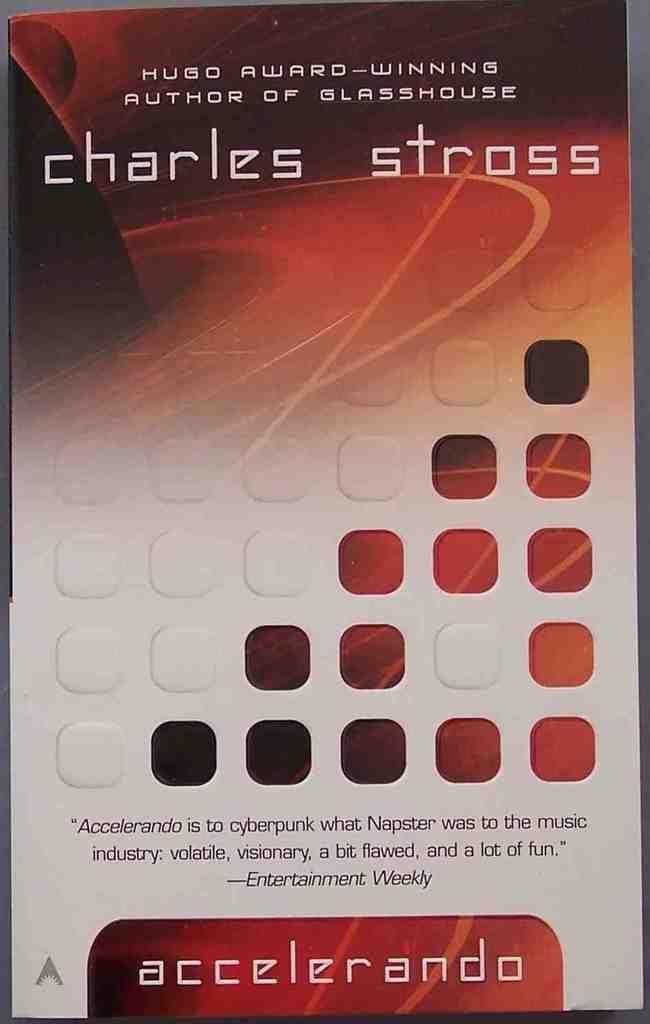What type of document is shown in the image? The image is a pamphlet. What can be found on the pamphlet? There are words on the pamphlet. Can you see a snake made of wool on the trail in the image? There is no snake made of wool or any trail present in the image; it is a pamphlet with words on it. 